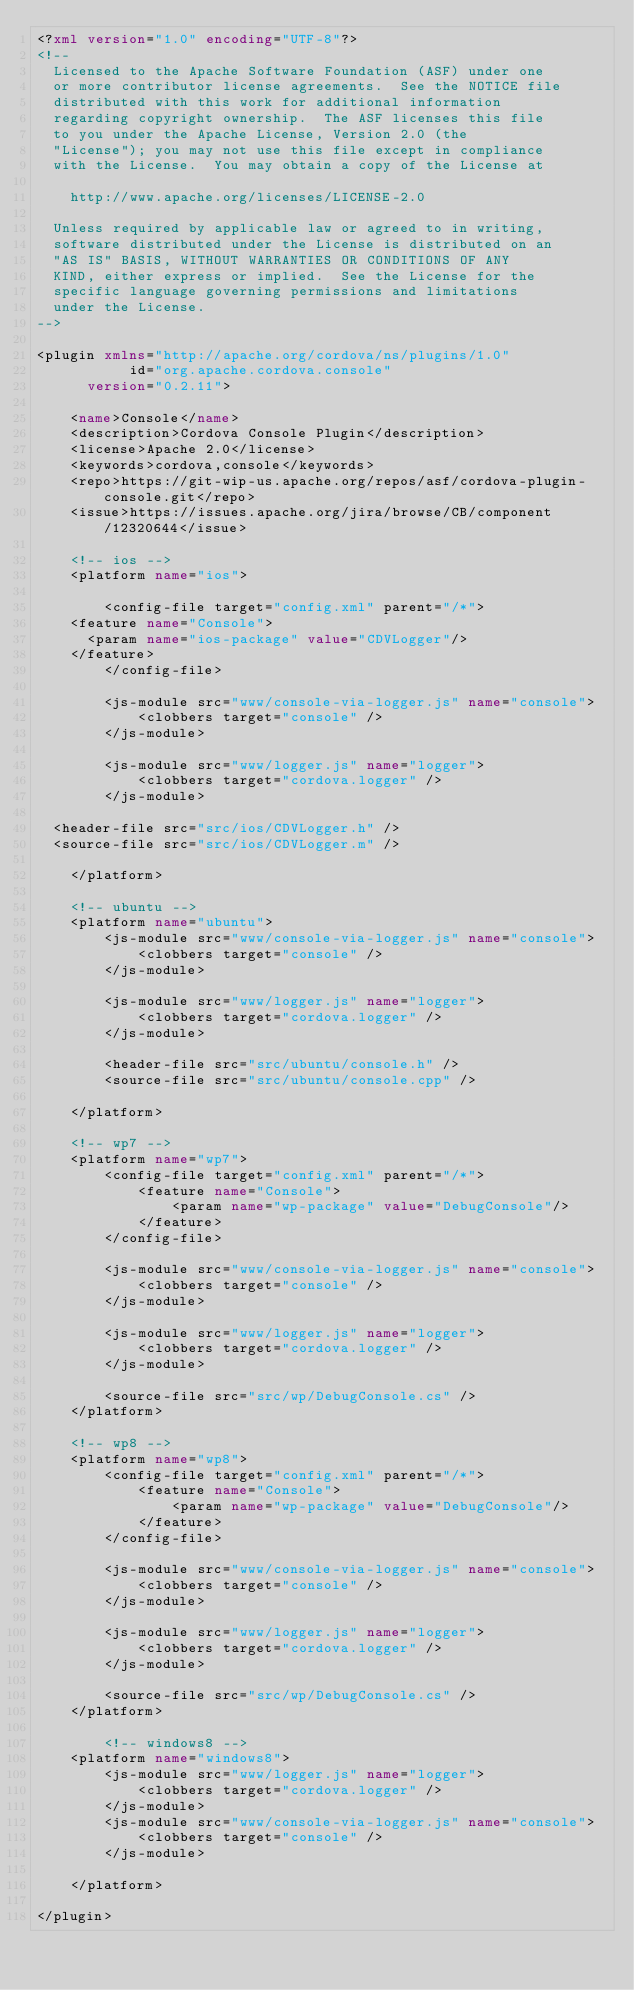Convert code to text. <code><loc_0><loc_0><loc_500><loc_500><_XML_><?xml version="1.0" encoding="UTF-8"?>
<!--
  Licensed to the Apache Software Foundation (ASF) under one
  or more contributor license agreements.  See the NOTICE file
  distributed with this work for additional information
  regarding copyright ownership.  The ASF licenses this file
  to you under the Apache License, Version 2.0 (the
  "License"); you may not use this file except in compliance
  with the License.  You may obtain a copy of the License at

    http://www.apache.org/licenses/LICENSE-2.0

  Unless required by applicable law or agreed to in writing,
  software distributed under the License is distributed on an
  "AS IS" BASIS, WITHOUT WARRANTIES OR CONDITIONS OF ANY
  KIND, either express or implied.  See the License for the
  specific language governing permissions and limitations
  under the License.
-->

<plugin xmlns="http://apache.org/cordova/ns/plugins/1.0"
           id="org.apache.cordova.console"
      version="0.2.11">

    <name>Console</name>
    <description>Cordova Console Plugin</description>
    <license>Apache 2.0</license>
    <keywords>cordova,console</keywords>
    <repo>https://git-wip-us.apache.org/repos/asf/cordova-plugin-console.git</repo>
    <issue>https://issues.apache.org/jira/browse/CB/component/12320644</issue>

    <!-- ios -->
    <platform name="ios">

        <config-file target="config.xml" parent="/*">
		<feature name="Console">
			<param name="ios-package" value="CDVLogger"/>
		</feature>
        </config-file>

        <js-module src="www/console-via-logger.js" name="console">
            <clobbers target="console" />
        </js-module>

        <js-module src="www/logger.js" name="logger">
            <clobbers target="cordova.logger" />
        </js-module>

	<header-file src="src/ios/CDVLogger.h" />
	<source-file src="src/ios/CDVLogger.m" />

    </platform>

    <!-- ubuntu -->
    <platform name="ubuntu">
        <js-module src="www/console-via-logger.js" name="console">
            <clobbers target="console" />
        </js-module>

        <js-module src="www/logger.js" name="logger">
            <clobbers target="cordova.logger" />
        </js-module>

        <header-file src="src/ubuntu/console.h" />
        <source-file src="src/ubuntu/console.cpp" />

    </platform>

    <!-- wp7 -->
    <platform name="wp7">
        <config-file target="config.xml" parent="/*">
            <feature name="Console">
                <param name="wp-package" value="DebugConsole"/>
            </feature>
        </config-file>

        <js-module src="www/console-via-logger.js" name="console">
            <clobbers target="console" />
        </js-module>

        <js-module src="www/logger.js" name="logger">
            <clobbers target="cordova.logger" />
        </js-module>

        <source-file src="src/wp/DebugConsole.cs" />
    </platform>

    <!-- wp8 -->
    <platform name="wp8">
        <config-file target="config.xml" parent="/*">
            <feature name="Console">
                <param name="wp-package" value="DebugConsole"/>
            </feature>
        </config-file>

        <js-module src="www/console-via-logger.js" name="console">
            <clobbers target="console" />
        </js-module>

        <js-module src="www/logger.js" name="logger">
            <clobbers target="cordova.logger" />
        </js-module>

        <source-file src="src/wp/DebugConsole.cs" />
    </platform>

        <!-- windows8 -->
    <platform name="windows8">
        <js-module src="www/logger.js" name="logger">
            <clobbers target="cordova.logger" />
        </js-module>
        <js-module src="www/console-via-logger.js" name="console">
            <clobbers target="console" />
        </js-module>

    </platform>

</plugin>
</code> 